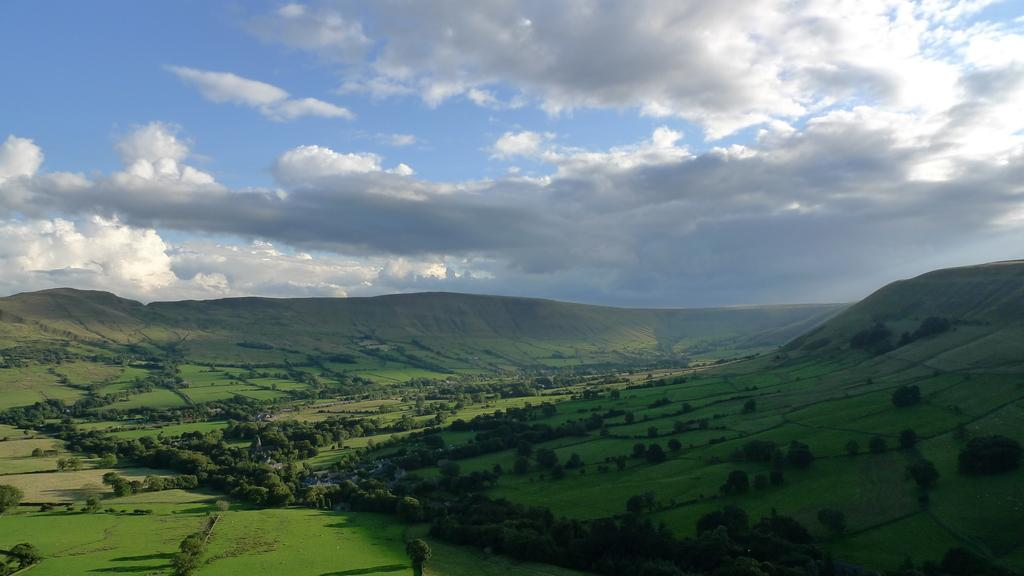What type of vegetation can be seen in the image? There is grass in the image. Are there any other plants visible in the image? Yes, there are trees in the image. What can be seen in the background of the image? The sky is visible in the background of the image. How do the clouds in the sky appear? The clouds in the sky appear heavy. What type of rice is being harvested in the image? There is no rice or harvesting activity present in the image. Can you tell me which branch of the tree is the heaviest in the image? There is no specific branch mentioned in the image, and the image does not provide enough information to determine which branch is the heaviest. 